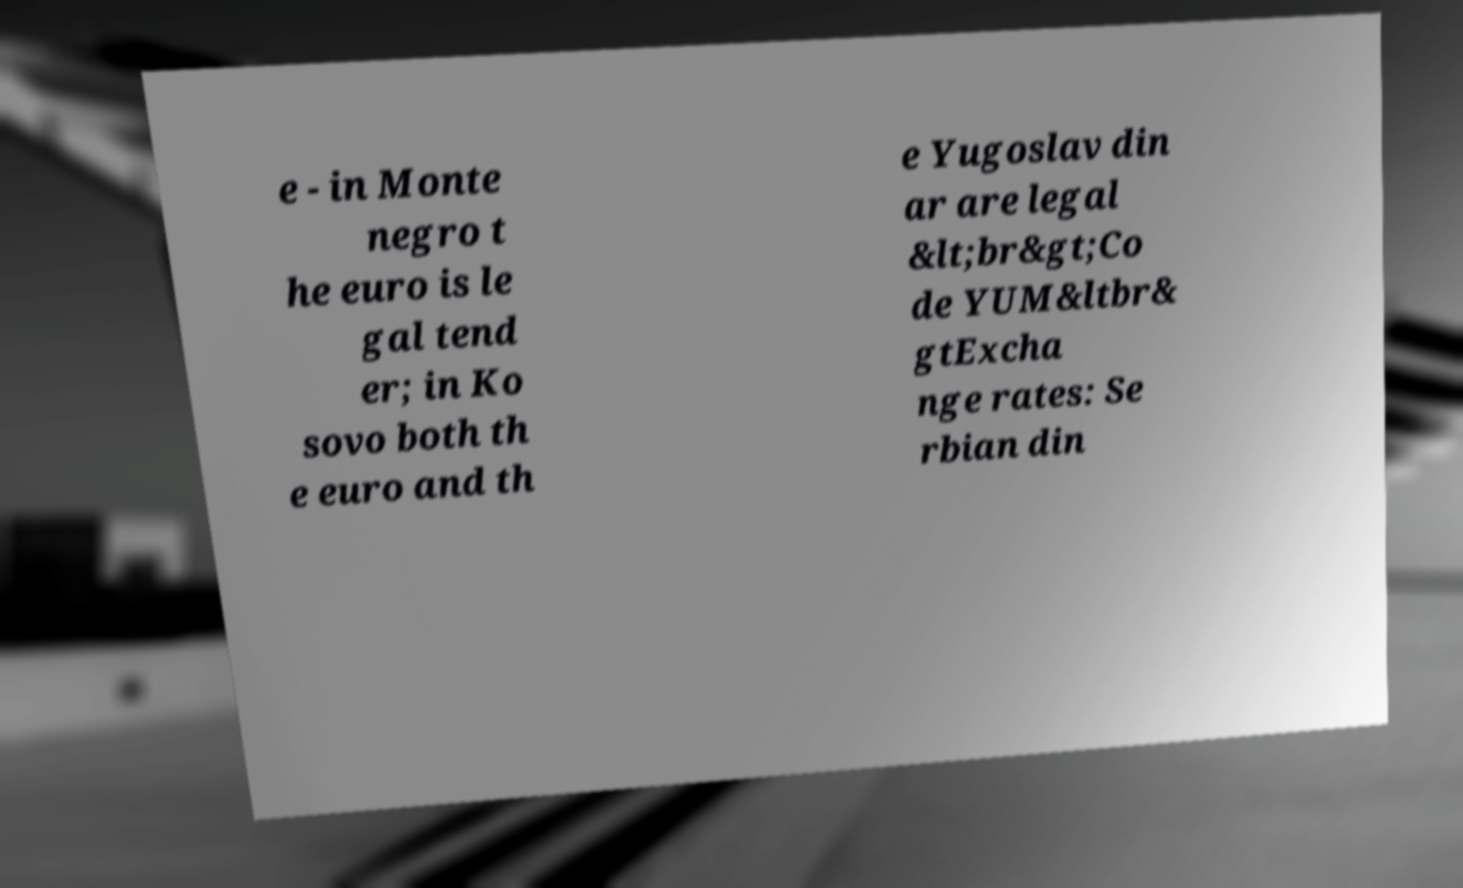Can you read and provide the text displayed in the image?This photo seems to have some interesting text. Can you extract and type it out for me? e - in Monte negro t he euro is le gal tend er; in Ko sovo both th e euro and th e Yugoslav din ar are legal &lt;br&gt;Co de YUM&ltbr& gtExcha nge rates: Se rbian din 